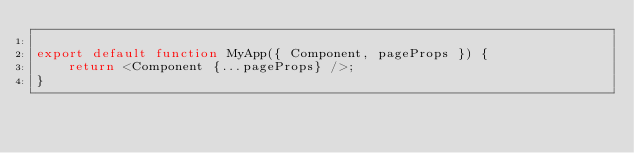Convert code to text. <code><loc_0><loc_0><loc_500><loc_500><_JavaScript_>
export default function MyApp({ Component, pageProps }) {
    return <Component {...pageProps} />;
}
</code> 